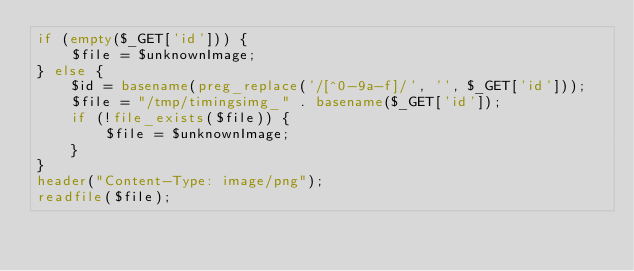Convert code to text. <code><loc_0><loc_0><loc_500><loc_500><_PHP_>if (empty($_GET['id'])) {
	$file = $unknownImage;
} else {
	$id = basename(preg_replace('/[^0-9a-f]/', '', $_GET['id']));
	$file = "/tmp/timingsimg_" . basename($_GET['id']);
	if (!file_exists($file)) {
		$file = $unknownImage;
	}
}
header("Content-Type: image/png");
readfile($file);
</code> 